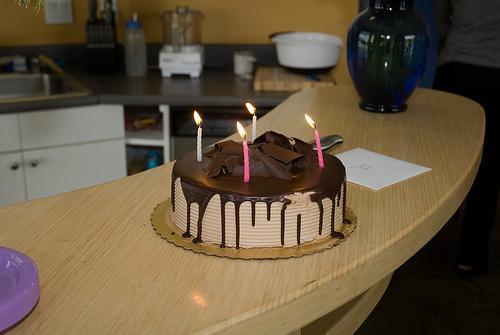How many candles are on the cake?
Give a very brief answer. 4. 